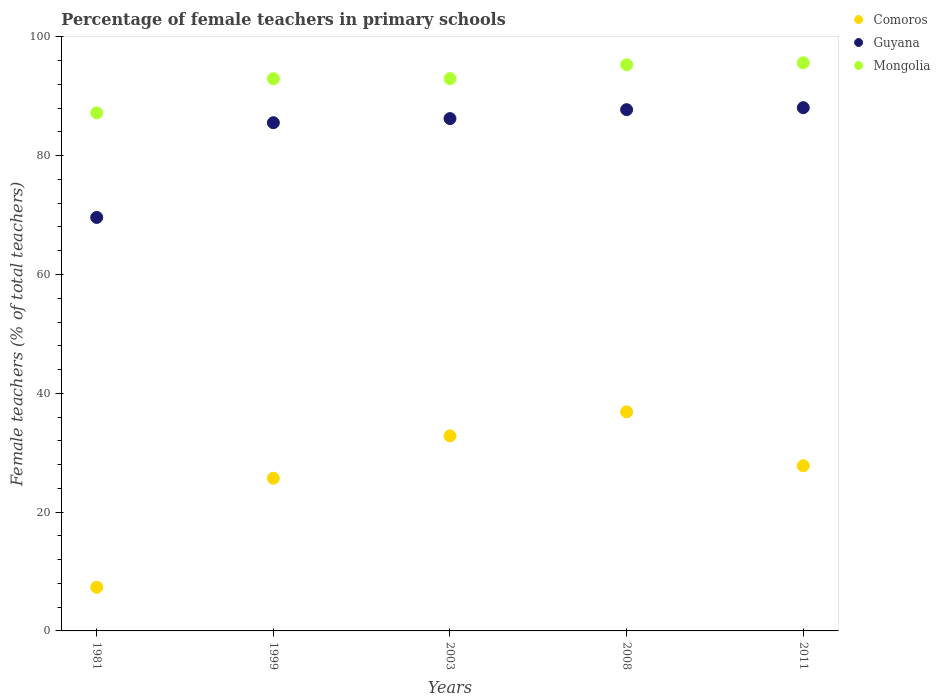How many different coloured dotlines are there?
Keep it short and to the point. 3. What is the percentage of female teachers in Comoros in 2008?
Offer a terse response. 36.88. Across all years, what is the maximum percentage of female teachers in Mongolia?
Offer a very short reply. 95.64. Across all years, what is the minimum percentage of female teachers in Mongolia?
Ensure brevity in your answer.  87.21. In which year was the percentage of female teachers in Mongolia maximum?
Offer a very short reply. 2011. In which year was the percentage of female teachers in Mongolia minimum?
Your response must be concise. 1981. What is the total percentage of female teachers in Guyana in the graph?
Provide a short and direct response. 417.25. What is the difference between the percentage of female teachers in Mongolia in 1981 and that in 2011?
Give a very brief answer. -8.43. What is the difference between the percentage of female teachers in Mongolia in 1999 and the percentage of female teachers in Guyana in 2008?
Provide a short and direct response. 5.21. What is the average percentage of female teachers in Guyana per year?
Your response must be concise. 83.45. In the year 1999, what is the difference between the percentage of female teachers in Comoros and percentage of female teachers in Mongolia?
Provide a short and direct response. -67.25. In how many years, is the percentage of female teachers in Comoros greater than 32 %?
Offer a very short reply. 2. What is the ratio of the percentage of female teachers in Comoros in 1999 to that in 2011?
Make the answer very short. 0.92. What is the difference between the highest and the second highest percentage of female teachers in Guyana?
Provide a succinct answer. 0.34. What is the difference between the highest and the lowest percentage of female teachers in Comoros?
Your response must be concise. 29.53. Is the sum of the percentage of female teachers in Mongolia in 2008 and 2011 greater than the maximum percentage of female teachers in Comoros across all years?
Ensure brevity in your answer.  Yes. Is it the case that in every year, the sum of the percentage of female teachers in Guyana and percentage of female teachers in Mongolia  is greater than the percentage of female teachers in Comoros?
Provide a short and direct response. Yes. Does the percentage of female teachers in Guyana monotonically increase over the years?
Offer a terse response. Yes. How many years are there in the graph?
Your response must be concise. 5. What is the difference between two consecutive major ticks on the Y-axis?
Your answer should be very brief. 20. Are the values on the major ticks of Y-axis written in scientific E-notation?
Provide a succinct answer. No. Does the graph contain grids?
Ensure brevity in your answer.  No. How many legend labels are there?
Ensure brevity in your answer.  3. What is the title of the graph?
Your answer should be compact. Percentage of female teachers in primary schools. What is the label or title of the Y-axis?
Provide a short and direct response. Female teachers (% of total teachers). What is the Female teachers (% of total teachers) in Comoros in 1981?
Offer a terse response. 7.35. What is the Female teachers (% of total teachers) of Guyana in 1981?
Keep it short and to the point. 69.61. What is the Female teachers (% of total teachers) of Mongolia in 1981?
Provide a succinct answer. 87.21. What is the Female teachers (% of total teachers) of Comoros in 1999?
Provide a short and direct response. 25.7. What is the Female teachers (% of total teachers) in Guyana in 1999?
Ensure brevity in your answer.  85.55. What is the Female teachers (% of total teachers) of Mongolia in 1999?
Make the answer very short. 92.95. What is the Female teachers (% of total teachers) of Comoros in 2003?
Offer a terse response. 32.84. What is the Female teachers (% of total teachers) of Guyana in 2003?
Keep it short and to the point. 86.25. What is the Female teachers (% of total teachers) in Mongolia in 2003?
Keep it short and to the point. 92.97. What is the Female teachers (% of total teachers) of Comoros in 2008?
Your response must be concise. 36.88. What is the Female teachers (% of total teachers) of Guyana in 2008?
Give a very brief answer. 87.75. What is the Female teachers (% of total teachers) of Mongolia in 2008?
Offer a very short reply. 95.31. What is the Female teachers (% of total teachers) in Comoros in 2011?
Your answer should be very brief. 27.8. What is the Female teachers (% of total teachers) in Guyana in 2011?
Offer a terse response. 88.09. What is the Female teachers (% of total teachers) of Mongolia in 2011?
Your answer should be compact. 95.64. Across all years, what is the maximum Female teachers (% of total teachers) in Comoros?
Ensure brevity in your answer.  36.88. Across all years, what is the maximum Female teachers (% of total teachers) of Guyana?
Your answer should be compact. 88.09. Across all years, what is the maximum Female teachers (% of total teachers) in Mongolia?
Give a very brief answer. 95.64. Across all years, what is the minimum Female teachers (% of total teachers) in Comoros?
Make the answer very short. 7.35. Across all years, what is the minimum Female teachers (% of total teachers) of Guyana?
Give a very brief answer. 69.61. Across all years, what is the minimum Female teachers (% of total teachers) in Mongolia?
Offer a very short reply. 87.21. What is the total Female teachers (% of total teachers) of Comoros in the graph?
Keep it short and to the point. 130.58. What is the total Female teachers (% of total teachers) of Guyana in the graph?
Provide a short and direct response. 417.25. What is the total Female teachers (% of total teachers) in Mongolia in the graph?
Provide a short and direct response. 464.09. What is the difference between the Female teachers (% of total teachers) in Comoros in 1981 and that in 1999?
Ensure brevity in your answer.  -18.35. What is the difference between the Female teachers (% of total teachers) of Guyana in 1981 and that in 1999?
Offer a terse response. -15.95. What is the difference between the Female teachers (% of total teachers) of Mongolia in 1981 and that in 1999?
Give a very brief answer. -5.74. What is the difference between the Female teachers (% of total teachers) in Comoros in 1981 and that in 2003?
Provide a succinct answer. -25.49. What is the difference between the Female teachers (% of total teachers) in Guyana in 1981 and that in 2003?
Your answer should be very brief. -16.64. What is the difference between the Female teachers (% of total teachers) in Mongolia in 1981 and that in 2003?
Offer a terse response. -5.76. What is the difference between the Female teachers (% of total teachers) in Comoros in 1981 and that in 2008?
Your response must be concise. -29.53. What is the difference between the Female teachers (% of total teachers) in Guyana in 1981 and that in 2008?
Offer a very short reply. -18.14. What is the difference between the Female teachers (% of total teachers) of Mongolia in 1981 and that in 2008?
Offer a terse response. -8.1. What is the difference between the Female teachers (% of total teachers) in Comoros in 1981 and that in 2011?
Offer a very short reply. -20.45. What is the difference between the Female teachers (% of total teachers) in Guyana in 1981 and that in 2011?
Keep it short and to the point. -18.48. What is the difference between the Female teachers (% of total teachers) of Mongolia in 1981 and that in 2011?
Give a very brief answer. -8.43. What is the difference between the Female teachers (% of total teachers) of Comoros in 1999 and that in 2003?
Offer a terse response. -7.14. What is the difference between the Female teachers (% of total teachers) in Guyana in 1999 and that in 2003?
Provide a short and direct response. -0.69. What is the difference between the Female teachers (% of total teachers) of Mongolia in 1999 and that in 2003?
Your answer should be compact. -0.02. What is the difference between the Female teachers (% of total teachers) of Comoros in 1999 and that in 2008?
Offer a very short reply. -11.18. What is the difference between the Female teachers (% of total teachers) of Guyana in 1999 and that in 2008?
Give a very brief answer. -2.2. What is the difference between the Female teachers (% of total teachers) in Mongolia in 1999 and that in 2008?
Give a very brief answer. -2.35. What is the difference between the Female teachers (% of total teachers) in Comoros in 1999 and that in 2011?
Provide a succinct answer. -2.1. What is the difference between the Female teachers (% of total teachers) of Guyana in 1999 and that in 2011?
Give a very brief answer. -2.53. What is the difference between the Female teachers (% of total teachers) of Mongolia in 1999 and that in 2011?
Offer a terse response. -2.68. What is the difference between the Female teachers (% of total teachers) in Comoros in 2003 and that in 2008?
Provide a short and direct response. -4.04. What is the difference between the Female teachers (% of total teachers) in Guyana in 2003 and that in 2008?
Offer a terse response. -1.5. What is the difference between the Female teachers (% of total teachers) of Mongolia in 2003 and that in 2008?
Keep it short and to the point. -2.33. What is the difference between the Female teachers (% of total teachers) in Comoros in 2003 and that in 2011?
Offer a terse response. 5.04. What is the difference between the Female teachers (% of total teachers) in Guyana in 2003 and that in 2011?
Provide a short and direct response. -1.84. What is the difference between the Female teachers (% of total teachers) of Mongolia in 2003 and that in 2011?
Offer a terse response. -2.67. What is the difference between the Female teachers (% of total teachers) of Comoros in 2008 and that in 2011?
Make the answer very short. 9.08. What is the difference between the Female teachers (% of total teachers) in Guyana in 2008 and that in 2011?
Keep it short and to the point. -0.34. What is the difference between the Female teachers (% of total teachers) of Mongolia in 2008 and that in 2011?
Your answer should be very brief. -0.33. What is the difference between the Female teachers (% of total teachers) in Comoros in 1981 and the Female teachers (% of total teachers) in Guyana in 1999?
Provide a short and direct response. -78.2. What is the difference between the Female teachers (% of total teachers) of Comoros in 1981 and the Female teachers (% of total teachers) of Mongolia in 1999?
Make the answer very short. -85.6. What is the difference between the Female teachers (% of total teachers) of Guyana in 1981 and the Female teachers (% of total teachers) of Mongolia in 1999?
Provide a short and direct response. -23.35. What is the difference between the Female teachers (% of total teachers) in Comoros in 1981 and the Female teachers (% of total teachers) in Guyana in 2003?
Offer a terse response. -78.9. What is the difference between the Female teachers (% of total teachers) in Comoros in 1981 and the Female teachers (% of total teachers) in Mongolia in 2003?
Ensure brevity in your answer.  -85.62. What is the difference between the Female teachers (% of total teachers) in Guyana in 1981 and the Female teachers (% of total teachers) in Mongolia in 2003?
Provide a succinct answer. -23.37. What is the difference between the Female teachers (% of total teachers) of Comoros in 1981 and the Female teachers (% of total teachers) of Guyana in 2008?
Offer a very short reply. -80.4. What is the difference between the Female teachers (% of total teachers) in Comoros in 1981 and the Female teachers (% of total teachers) in Mongolia in 2008?
Provide a short and direct response. -87.96. What is the difference between the Female teachers (% of total teachers) in Guyana in 1981 and the Female teachers (% of total teachers) in Mongolia in 2008?
Offer a terse response. -25.7. What is the difference between the Female teachers (% of total teachers) of Comoros in 1981 and the Female teachers (% of total teachers) of Guyana in 2011?
Offer a terse response. -80.73. What is the difference between the Female teachers (% of total teachers) in Comoros in 1981 and the Female teachers (% of total teachers) in Mongolia in 2011?
Your answer should be very brief. -88.29. What is the difference between the Female teachers (% of total teachers) in Guyana in 1981 and the Female teachers (% of total teachers) in Mongolia in 2011?
Your answer should be very brief. -26.03. What is the difference between the Female teachers (% of total teachers) in Comoros in 1999 and the Female teachers (% of total teachers) in Guyana in 2003?
Offer a terse response. -60.54. What is the difference between the Female teachers (% of total teachers) of Comoros in 1999 and the Female teachers (% of total teachers) of Mongolia in 2003?
Keep it short and to the point. -67.27. What is the difference between the Female teachers (% of total teachers) in Guyana in 1999 and the Female teachers (% of total teachers) in Mongolia in 2003?
Your answer should be compact. -7.42. What is the difference between the Female teachers (% of total teachers) of Comoros in 1999 and the Female teachers (% of total teachers) of Guyana in 2008?
Provide a succinct answer. -62.05. What is the difference between the Female teachers (% of total teachers) in Comoros in 1999 and the Female teachers (% of total teachers) in Mongolia in 2008?
Offer a very short reply. -69.6. What is the difference between the Female teachers (% of total teachers) of Guyana in 1999 and the Female teachers (% of total teachers) of Mongolia in 2008?
Give a very brief answer. -9.75. What is the difference between the Female teachers (% of total teachers) in Comoros in 1999 and the Female teachers (% of total teachers) in Guyana in 2011?
Provide a short and direct response. -62.38. What is the difference between the Female teachers (% of total teachers) of Comoros in 1999 and the Female teachers (% of total teachers) of Mongolia in 2011?
Your answer should be very brief. -69.94. What is the difference between the Female teachers (% of total teachers) of Guyana in 1999 and the Female teachers (% of total teachers) of Mongolia in 2011?
Your answer should be compact. -10.09. What is the difference between the Female teachers (% of total teachers) of Comoros in 2003 and the Female teachers (% of total teachers) of Guyana in 2008?
Offer a terse response. -54.91. What is the difference between the Female teachers (% of total teachers) of Comoros in 2003 and the Female teachers (% of total teachers) of Mongolia in 2008?
Your answer should be compact. -62.47. What is the difference between the Female teachers (% of total teachers) of Guyana in 2003 and the Female teachers (% of total teachers) of Mongolia in 2008?
Offer a terse response. -9.06. What is the difference between the Female teachers (% of total teachers) of Comoros in 2003 and the Female teachers (% of total teachers) of Guyana in 2011?
Provide a short and direct response. -55.25. What is the difference between the Female teachers (% of total teachers) of Comoros in 2003 and the Female teachers (% of total teachers) of Mongolia in 2011?
Keep it short and to the point. -62.8. What is the difference between the Female teachers (% of total teachers) in Guyana in 2003 and the Female teachers (% of total teachers) in Mongolia in 2011?
Offer a terse response. -9.39. What is the difference between the Female teachers (% of total teachers) in Comoros in 2008 and the Female teachers (% of total teachers) in Guyana in 2011?
Provide a succinct answer. -51.21. What is the difference between the Female teachers (% of total teachers) of Comoros in 2008 and the Female teachers (% of total teachers) of Mongolia in 2011?
Your answer should be compact. -58.76. What is the difference between the Female teachers (% of total teachers) in Guyana in 2008 and the Female teachers (% of total teachers) in Mongolia in 2011?
Make the answer very short. -7.89. What is the average Female teachers (% of total teachers) in Comoros per year?
Make the answer very short. 26.12. What is the average Female teachers (% of total teachers) in Guyana per year?
Your response must be concise. 83.45. What is the average Female teachers (% of total teachers) in Mongolia per year?
Offer a very short reply. 92.82. In the year 1981, what is the difference between the Female teachers (% of total teachers) in Comoros and Female teachers (% of total teachers) in Guyana?
Ensure brevity in your answer.  -62.26. In the year 1981, what is the difference between the Female teachers (% of total teachers) of Comoros and Female teachers (% of total teachers) of Mongolia?
Offer a very short reply. -79.86. In the year 1981, what is the difference between the Female teachers (% of total teachers) in Guyana and Female teachers (% of total teachers) in Mongolia?
Your response must be concise. -17.6. In the year 1999, what is the difference between the Female teachers (% of total teachers) in Comoros and Female teachers (% of total teachers) in Guyana?
Offer a terse response. -59.85. In the year 1999, what is the difference between the Female teachers (% of total teachers) in Comoros and Female teachers (% of total teachers) in Mongolia?
Ensure brevity in your answer.  -67.25. In the year 1999, what is the difference between the Female teachers (% of total teachers) of Guyana and Female teachers (% of total teachers) of Mongolia?
Ensure brevity in your answer.  -7.4. In the year 2003, what is the difference between the Female teachers (% of total teachers) of Comoros and Female teachers (% of total teachers) of Guyana?
Your answer should be compact. -53.41. In the year 2003, what is the difference between the Female teachers (% of total teachers) of Comoros and Female teachers (% of total teachers) of Mongolia?
Offer a terse response. -60.13. In the year 2003, what is the difference between the Female teachers (% of total teachers) of Guyana and Female teachers (% of total teachers) of Mongolia?
Provide a short and direct response. -6.73. In the year 2008, what is the difference between the Female teachers (% of total teachers) in Comoros and Female teachers (% of total teachers) in Guyana?
Your answer should be very brief. -50.87. In the year 2008, what is the difference between the Female teachers (% of total teachers) in Comoros and Female teachers (% of total teachers) in Mongolia?
Provide a succinct answer. -58.43. In the year 2008, what is the difference between the Female teachers (% of total teachers) of Guyana and Female teachers (% of total teachers) of Mongolia?
Provide a short and direct response. -7.56. In the year 2011, what is the difference between the Female teachers (% of total teachers) of Comoros and Female teachers (% of total teachers) of Guyana?
Your answer should be compact. -60.28. In the year 2011, what is the difference between the Female teachers (% of total teachers) in Comoros and Female teachers (% of total teachers) in Mongolia?
Provide a succinct answer. -67.84. In the year 2011, what is the difference between the Female teachers (% of total teachers) of Guyana and Female teachers (% of total teachers) of Mongolia?
Your answer should be very brief. -7.55. What is the ratio of the Female teachers (% of total teachers) of Comoros in 1981 to that in 1999?
Your answer should be very brief. 0.29. What is the ratio of the Female teachers (% of total teachers) in Guyana in 1981 to that in 1999?
Offer a very short reply. 0.81. What is the ratio of the Female teachers (% of total teachers) in Mongolia in 1981 to that in 1999?
Give a very brief answer. 0.94. What is the ratio of the Female teachers (% of total teachers) of Comoros in 1981 to that in 2003?
Offer a very short reply. 0.22. What is the ratio of the Female teachers (% of total teachers) of Guyana in 1981 to that in 2003?
Your response must be concise. 0.81. What is the ratio of the Female teachers (% of total teachers) of Mongolia in 1981 to that in 2003?
Your answer should be very brief. 0.94. What is the ratio of the Female teachers (% of total teachers) in Comoros in 1981 to that in 2008?
Give a very brief answer. 0.2. What is the ratio of the Female teachers (% of total teachers) of Guyana in 1981 to that in 2008?
Your answer should be very brief. 0.79. What is the ratio of the Female teachers (% of total teachers) in Mongolia in 1981 to that in 2008?
Offer a terse response. 0.92. What is the ratio of the Female teachers (% of total teachers) of Comoros in 1981 to that in 2011?
Your response must be concise. 0.26. What is the ratio of the Female teachers (% of total teachers) of Guyana in 1981 to that in 2011?
Offer a very short reply. 0.79. What is the ratio of the Female teachers (% of total teachers) in Mongolia in 1981 to that in 2011?
Give a very brief answer. 0.91. What is the ratio of the Female teachers (% of total teachers) in Comoros in 1999 to that in 2003?
Provide a short and direct response. 0.78. What is the ratio of the Female teachers (% of total teachers) of Guyana in 1999 to that in 2003?
Make the answer very short. 0.99. What is the ratio of the Female teachers (% of total teachers) of Mongolia in 1999 to that in 2003?
Provide a short and direct response. 1. What is the ratio of the Female teachers (% of total teachers) in Comoros in 1999 to that in 2008?
Keep it short and to the point. 0.7. What is the ratio of the Female teachers (% of total teachers) of Guyana in 1999 to that in 2008?
Make the answer very short. 0.97. What is the ratio of the Female teachers (% of total teachers) of Mongolia in 1999 to that in 2008?
Make the answer very short. 0.98. What is the ratio of the Female teachers (% of total teachers) of Comoros in 1999 to that in 2011?
Offer a very short reply. 0.92. What is the ratio of the Female teachers (% of total teachers) of Guyana in 1999 to that in 2011?
Provide a short and direct response. 0.97. What is the ratio of the Female teachers (% of total teachers) in Mongolia in 1999 to that in 2011?
Your response must be concise. 0.97. What is the ratio of the Female teachers (% of total teachers) of Comoros in 2003 to that in 2008?
Provide a short and direct response. 0.89. What is the ratio of the Female teachers (% of total teachers) in Guyana in 2003 to that in 2008?
Offer a terse response. 0.98. What is the ratio of the Female teachers (% of total teachers) of Mongolia in 2003 to that in 2008?
Your answer should be compact. 0.98. What is the ratio of the Female teachers (% of total teachers) in Comoros in 2003 to that in 2011?
Ensure brevity in your answer.  1.18. What is the ratio of the Female teachers (% of total teachers) in Guyana in 2003 to that in 2011?
Keep it short and to the point. 0.98. What is the ratio of the Female teachers (% of total teachers) of Mongolia in 2003 to that in 2011?
Offer a terse response. 0.97. What is the ratio of the Female teachers (% of total teachers) of Comoros in 2008 to that in 2011?
Make the answer very short. 1.33. What is the ratio of the Female teachers (% of total teachers) of Guyana in 2008 to that in 2011?
Keep it short and to the point. 1. What is the ratio of the Female teachers (% of total teachers) of Mongolia in 2008 to that in 2011?
Give a very brief answer. 1. What is the difference between the highest and the second highest Female teachers (% of total teachers) of Comoros?
Ensure brevity in your answer.  4.04. What is the difference between the highest and the second highest Female teachers (% of total teachers) in Guyana?
Keep it short and to the point. 0.34. What is the difference between the highest and the second highest Female teachers (% of total teachers) of Mongolia?
Your answer should be very brief. 0.33. What is the difference between the highest and the lowest Female teachers (% of total teachers) of Comoros?
Keep it short and to the point. 29.53. What is the difference between the highest and the lowest Female teachers (% of total teachers) in Guyana?
Your response must be concise. 18.48. What is the difference between the highest and the lowest Female teachers (% of total teachers) in Mongolia?
Provide a short and direct response. 8.43. 